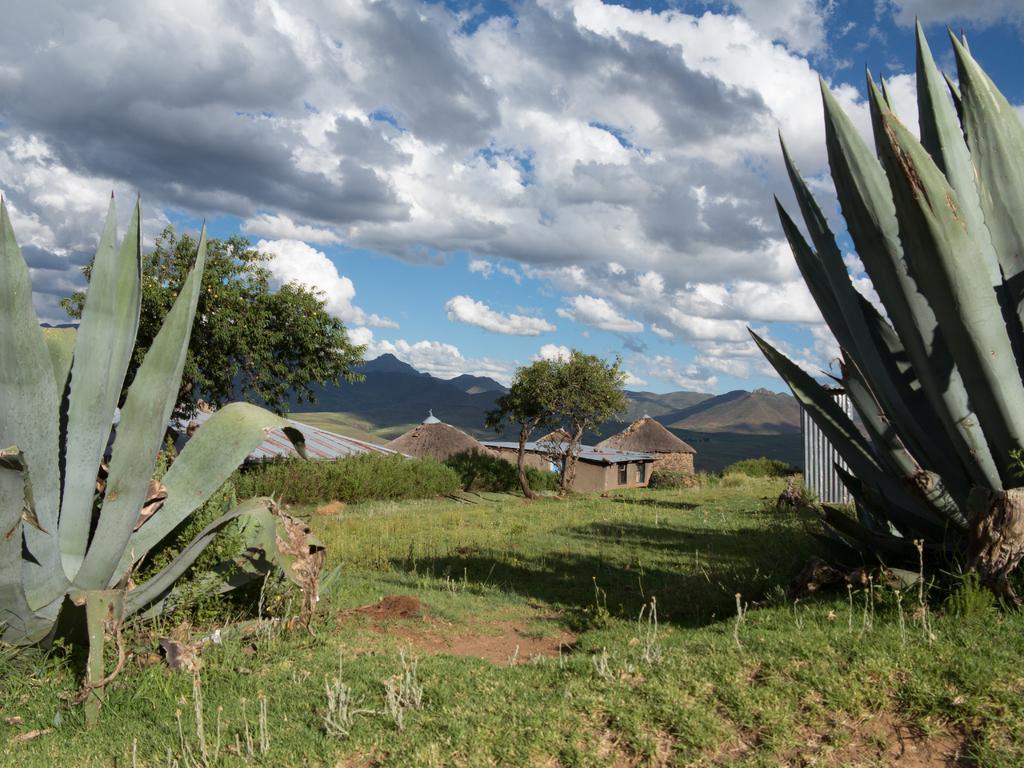In one or two sentences, can you explain what this image depicts? In the picture we can see a grass surface on it, we can see some plants and far away from it, we can see some plants and beside it, we can see some hurts and behind it we can see some hills and sky with clouds. 